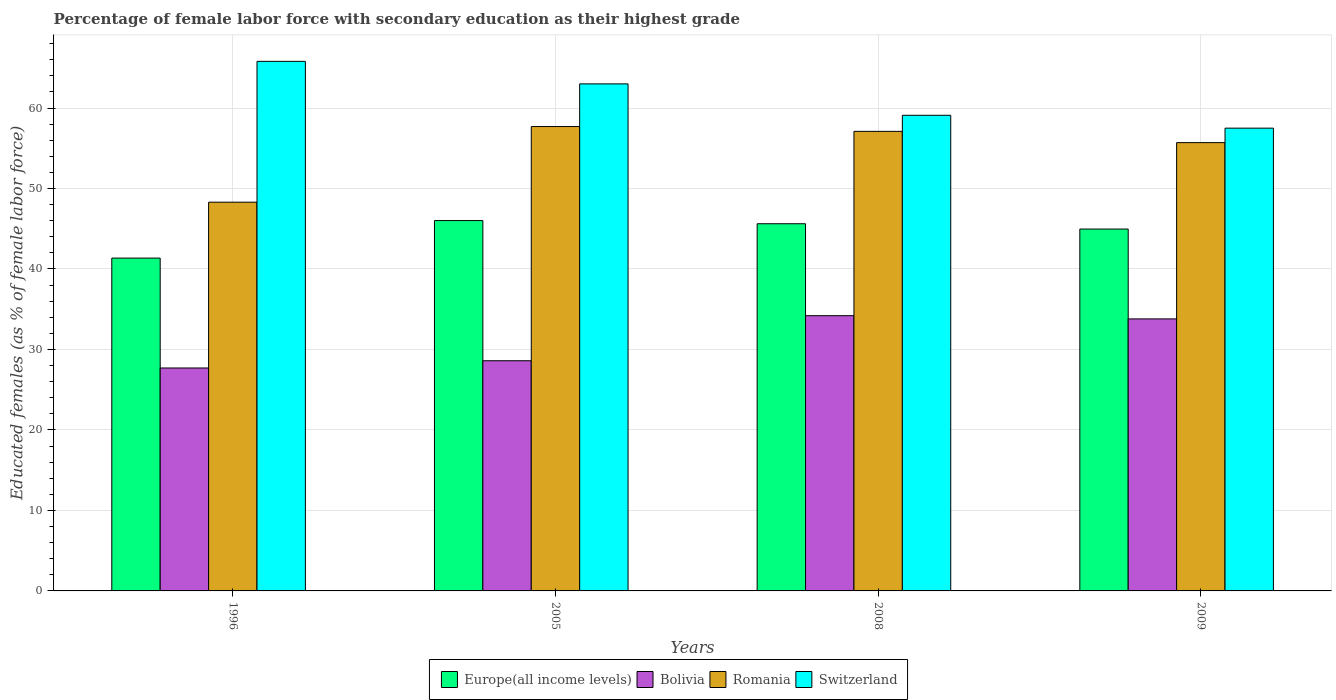Are the number of bars on each tick of the X-axis equal?
Your answer should be compact. Yes. How many bars are there on the 4th tick from the left?
Make the answer very short. 4. How many bars are there on the 4th tick from the right?
Make the answer very short. 4. What is the label of the 2nd group of bars from the left?
Give a very brief answer. 2005. In how many cases, is the number of bars for a given year not equal to the number of legend labels?
Keep it short and to the point. 0. What is the percentage of female labor force with secondary education in Switzerland in 1996?
Make the answer very short. 65.8. Across all years, what is the maximum percentage of female labor force with secondary education in Europe(all income levels)?
Make the answer very short. 46.02. Across all years, what is the minimum percentage of female labor force with secondary education in Romania?
Offer a terse response. 48.3. In which year was the percentage of female labor force with secondary education in Switzerland maximum?
Offer a terse response. 1996. What is the total percentage of female labor force with secondary education in Bolivia in the graph?
Make the answer very short. 124.3. What is the difference between the percentage of female labor force with secondary education in Switzerland in 1996 and that in 2005?
Offer a terse response. 2.8. What is the difference between the percentage of female labor force with secondary education in Switzerland in 2005 and the percentage of female labor force with secondary education in Bolivia in 2009?
Your response must be concise. 29.2. What is the average percentage of female labor force with secondary education in Europe(all income levels) per year?
Provide a succinct answer. 44.49. In the year 2009, what is the difference between the percentage of female labor force with secondary education in Switzerland and percentage of female labor force with secondary education in Romania?
Offer a terse response. 1.8. In how many years, is the percentage of female labor force with secondary education in Switzerland greater than 66 %?
Provide a succinct answer. 0. What is the ratio of the percentage of female labor force with secondary education in Europe(all income levels) in 1996 to that in 2009?
Give a very brief answer. 0.92. What is the difference between the highest and the second highest percentage of female labor force with secondary education in Europe(all income levels)?
Your answer should be compact. 0.39. What is the difference between the highest and the lowest percentage of female labor force with secondary education in Europe(all income levels)?
Keep it short and to the point. 4.66. In how many years, is the percentage of female labor force with secondary education in Switzerland greater than the average percentage of female labor force with secondary education in Switzerland taken over all years?
Provide a succinct answer. 2. Is the sum of the percentage of female labor force with secondary education in Europe(all income levels) in 1996 and 2005 greater than the maximum percentage of female labor force with secondary education in Bolivia across all years?
Offer a very short reply. Yes. What does the 4th bar from the left in 2009 represents?
Keep it short and to the point. Switzerland. What does the 2nd bar from the right in 2009 represents?
Give a very brief answer. Romania. Is it the case that in every year, the sum of the percentage of female labor force with secondary education in Europe(all income levels) and percentage of female labor force with secondary education in Romania is greater than the percentage of female labor force with secondary education in Bolivia?
Your answer should be very brief. Yes. How many years are there in the graph?
Ensure brevity in your answer.  4. Are the values on the major ticks of Y-axis written in scientific E-notation?
Make the answer very short. No. Does the graph contain any zero values?
Your answer should be compact. No. Does the graph contain grids?
Keep it short and to the point. Yes. Where does the legend appear in the graph?
Offer a terse response. Bottom center. How many legend labels are there?
Make the answer very short. 4. How are the legend labels stacked?
Keep it short and to the point. Horizontal. What is the title of the graph?
Offer a very short reply. Percentage of female labor force with secondary education as their highest grade. What is the label or title of the X-axis?
Your answer should be very brief. Years. What is the label or title of the Y-axis?
Ensure brevity in your answer.  Educated females (as % of female labor force). What is the Educated females (as % of female labor force) in Europe(all income levels) in 1996?
Provide a short and direct response. 41.35. What is the Educated females (as % of female labor force) of Bolivia in 1996?
Your answer should be compact. 27.7. What is the Educated females (as % of female labor force) of Romania in 1996?
Provide a succinct answer. 48.3. What is the Educated females (as % of female labor force) of Switzerland in 1996?
Offer a very short reply. 65.8. What is the Educated females (as % of female labor force) in Europe(all income levels) in 2005?
Ensure brevity in your answer.  46.02. What is the Educated females (as % of female labor force) of Bolivia in 2005?
Give a very brief answer. 28.6. What is the Educated females (as % of female labor force) of Romania in 2005?
Provide a succinct answer. 57.7. What is the Educated females (as % of female labor force) of Europe(all income levels) in 2008?
Offer a very short reply. 45.62. What is the Educated females (as % of female labor force) in Bolivia in 2008?
Provide a succinct answer. 34.2. What is the Educated females (as % of female labor force) of Romania in 2008?
Provide a short and direct response. 57.1. What is the Educated females (as % of female labor force) in Switzerland in 2008?
Make the answer very short. 59.1. What is the Educated females (as % of female labor force) in Europe(all income levels) in 2009?
Ensure brevity in your answer.  44.96. What is the Educated females (as % of female labor force) of Bolivia in 2009?
Offer a very short reply. 33.8. What is the Educated females (as % of female labor force) of Romania in 2009?
Provide a short and direct response. 55.7. What is the Educated females (as % of female labor force) in Switzerland in 2009?
Your answer should be compact. 57.5. Across all years, what is the maximum Educated females (as % of female labor force) in Europe(all income levels)?
Offer a terse response. 46.02. Across all years, what is the maximum Educated females (as % of female labor force) of Bolivia?
Make the answer very short. 34.2. Across all years, what is the maximum Educated females (as % of female labor force) in Romania?
Keep it short and to the point. 57.7. Across all years, what is the maximum Educated females (as % of female labor force) in Switzerland?
Your answer should be very brief. 65.8. Across all years, what is the minimum Educated females (as % of female labor force) in Europe(all income levels)?
Keep it short and to the point. 41.35. Across all years, what is the minimum Educated females (as % of female labor force) in Bolivia?
Your response must be concise. 27.7. Across all years, what is the minimum Educated females (as % of female labor force) of Romania?
Provide a short and direct response. 48.3. Across all years, what is the minimum Educated females (as % of female labor force) in Switzerland?
Make the answer very short. 57.5. What is the total Educated females (as % of female labor force) in Europe(all income levels) in the graph?
Offer a very short reply. 177.96. What is the total Educated females (as % of female labor force) in Bolivia in the graph?
Your answer should be compact. 124.3. What is the total Educated females (as % of female labor force) of Romania in the graph?
Your response must be concise. 218.8. What is the total Educated females (as % of female labor force) in Switzerland in the graph?
Your response must be concise. 245.4. What is the difference between the Educated females (as % of female labor force) of Europe(all income levels) in 1996 and that in 2005?
Your answer should be compact. -4.66. What is the difference between the Educated females (as % of female labor force) of Romania in 1996 and that in 2005?
Make the answer very short. -9.4. What is the difference between the Educated females (as % of female labor force) in Europe(all income levels) in 1996 and that in 2008?
Your answer should be compact. -4.27. What is the difference between the Educated females (as % of female labor force) of Bolivia in 1996 and that in 2008?
Provide a short and direct response. -6.5. What is the difference between the Educated females (as % of female labor force) in Romania in 1996 and that in 2008?
Your answer should be very brief. -8.8. What is the difference between the Educated females (as % of female labor force) of Switzerland in 1996 and that in 2008?
Offer a terse response. 6.7. What is the difference between the Educated females (as % of female labor force) of Europe(all income levels) in 1996 and that in 2009?
Make the answer very short. -3.61. What is the difference between the Educated females (as % of female labor force) in Bolivia in 1996 and that in 2009?
Make the answer very short. -6.1. What is the difference between the Educated females (as % of female labor force) in Romania in 1996 and that in 2009?
Your answer should be compact. -7.4. What is the difference between the Educated females (as % of female labor force) in Switzerland in 1996 and that in 2009?
Make the answer very short. 8.3. What is the difference between the Educated females (as % of female labor force) in Europe(all income levels) in 2005 and that in 2008?
Your answer should be compact. 0.39. What is the difference between the Educated females (as % of female labor force) in Bolivia in 2005 and that in 2008?
Make the answer very short. -5.6. What is the difference between the Educated females (as % of female labor force) in Europe(all income levels) in 2005 and that in 2009?
Your answer should be very brief. 1.05. What is the difference between the Educated females (as % of female labor force) in Switzerland in 2005 and that in 2009?
Provide a short and direct response. 5.5. What is the difference between the Educated females (as % of female labor force) in Europe(all income levels) in 2008 and that in 2009?
Provide a short and direct response. 0.66. What is the difference between the Educated females (as % of female labor force) of Romania in 2008 and that in 2009?
Your response must be concise. 1.4. What is the difference between the Educated females (as % of female labor force) in Europe(all income levels) in 1996 and the Educated females (as % of female labor force) in Bolivia in 2005?
Your answer should be very brief. 12.75. What is the difference between the Educated females (as % of female labor force) of Europe(all income levels) in 1996 and the Educated females (as % of female labor force) of Romania in 2005?
Provide a short and direct response. -16.35. What is the difference between the Educated females (as % of female labor force) in Europe(all income levels) in 1996 and the Educated females (as % of female labor force) in Switzerland in 2005?
Offer a terse response. -21.65. What is the difference between the Educated females (as % of female labor force) of Bolivia in 1996 and the Educated females (as % of female labor force) of Romania in 2005?
Your answer should be very brief. -30. What is the difference between the Educated females (as % of female labor force) in Bolivia in 1996 and the Educated females (as % of female labor force) in Switzerland in 2005?
Your answer should be very brief. -35.3. What is the difference between the Educated females (as % of female labor force) of Romania in 1996 and the Educated females (as % of female labor force) of Switzerland in 2005?
Give a very brief answer. -14.7. What is the difference between the Educated females (as % of female labor force) in Europe(all income levels) in 1996 and the Educated females (as % of female labor force) in Bolivia in 2008?
Keep it short and to the point. 7.15. What is the difference between the Educated females (as % of female labor force) in Europe(all income levels) in 1996 and the Educated females (as % of female labor force) in Romania in 2008?
Your answer should be compact. -15.75. What is the difference between the Educated females (as % of female labor force) in Europe(all income levels) in 1996 and the Educated females (as % of female labor force) in Switzerland in 2008?
Keep it short and to the point. -17.75. What is the difference between the Educated females (as % of female labor force) in Bolivia in 1996 and the Educated females (as % of female labor force) in Romania in 2008?
Your answer should be compact. -29.4. What is the difference between the Educated females (as % of female labor force) in Bolivia in 1996 and the Educated females (as % of female labor force) in Switzerland in 2008?
Keep it short and to the point. -31.4. What is the difference between the Educated females (as % of female labor force) in Europe(all income levels) in 1996 and the Educated females (as % of female labor force) in Bolivia in 2009?
Give a very brief answer. 7.55. What is the difference between the Educated females (as % of female labor force) of Europe(all income levels) in 1996 and the Educated females (as % of female labor force) of Romania in 2009?
Offer a terse response. -14.35. What is the difference between the Educated females (as % of female labor force) in Europe(all income levels) in 1996 and the Educated females (as % of female labor force) in Switzerland in 2009?
Ensure brevity in your answer.  -16.15. What is the difference between the Educated females (as % of female labor force) of Bolivia in 1996 and the Educated females (as % of female labor force) of Switzerland in 2009?
Your answer should be compact. -29.8. What is the difference between the Educated females (as % of female labor force) of Europe(all income levels) in 2005 and the Educated females (as % of female labor force) of Bolivia in 2008?
Provide a succinct answer. 11.82. What is the difference between the Educated females (as % of female labor force) of Europe(all income levels) in 2005 and the Educated females (as % of female labor force) of Romania in 2008?
Give a very brief answer. -11.08. What is the difference between the Educated females (as % of female labor force) of Europe(all income levels) in 2005 and the Educated females (as % of female labor force) of Switzerland in 2008?
Keep it short and to the point. -13.08. What is the difference between the Educated females (as % of female labor force) of Bolivia in 2005 and the Educated females (as % of female labor force) of Romania in 2008?
Offer a very short reply. -28.5. What is the difference between the Educated females (as % of female labor force) of Bolivia in 2005 and the Educated females (as % of female labor force) of Switzerland in 2008?
Offer a very short reply. -30.5. What is the difference between the Educated females (as % of female labor force) in Romania in 2005 and the Educated females (as % of female labor force) in Switzerland in 2008?
Your response must be concise. -1.4. What is the difference between the Educated females (as % of female labor force) of Europe(all income levels) in 2005 and the Educated females (as % of female labor force) of Bolivia in 2009?
Your answer should be very brief. 12.22. What is the difference between the Educated females (as % of female labor force) in Europe(all income levels) in 2005 and the Educated females (as % of female labor force) in Romania in 2009?
Your answer should be very brief. -9.68. What is the difference between the Educated females (as % of female labor force) of Europe(all income levels) in 2005 and the Educated females (as % of female labor force) of Switzerland in 2009?
Provide a short and direct response. -11.48. What is the difference between the Educated females (as % of female labor force) of Bolivia in 2005 and the Educated females (as % of female labor force) of Romania in 2009?
Your response must be concise. -27.1. What is the difference between the Educated females (as % of female labor force) of Bolivia in 2005 and the Educated females (as % of female labor force) of Switzerland in 2009?
Offer a terse response. -28.9. What is the difference between the Educated females (as % of female labor force) of Romania in 2005 and the Educated females (as % of female labor force) of Switzerland in 2009?
Offer a terse response. 0.2. What is the difference between the Educated females (as % of female labor force) in Europe(all income levels) in 2008 and the Educated females (as % of female labor force) in Bolivia in 2009?
Provide a short and direct response. 11.82. What is the difference between the Educated females (as % of female labor force) of Europe(all income levels) in 2008 and the Educated females (as % of female labor force) of Romania in 2009?
Offer a very short reply. -10.08. What is the difference between the Educated females (as % of female labor force) of Europe(all income levels) in 2008 and the Educated females (as % of female labor force) of Switzerland in 2009?
Ensure brevity in your answer.  -11.88. What is the difference between the Educated females (as % of female labor force) in Bolivia in 2008 and the Educated females (as % of female labor force) in Romania in 2009?
Make the answer very short. -21.5. What is the difference between the Educated females (as % of female labor force) of Bolivia in 2008 and the Educated females (as % of female labor force) of Switzerland in 2009?
Provide a short and direct response. -23.3. What is the difference between the Educated females (as % of female labor force) in Romania in 2008 and the Educated females (as % of female labor force) in Switzerland in 2009?
Offer a terse response. -0.4. What is the average Educated females (as % of female labor force) of Europe(all income levels) per year?
Provide a succinct answer. 44.49. What is the average Educated females (as % of female labor force) in Bolivia per year?
Give a very brief answer. 31.07. What is the average Educated females (as % of female labor force) of Romania per year?
Your answer should be very brief. 54.7. What is the average Educated females (as % of female labor force) of Switzerland per year?
Provide a short and direct response. 61.35. In the year 1996, what is the difference between the Educated females (as % of female labor force) in Europe(all income levels) and Educated females (as % of female labor force) in Bolivia?
Provide a short and direct response. 13.65. In the year 1996, what is the difference between the Educated females (as % of female labor force) in Europe(all income levels) and Educated females (as % of female labor force) in Romania?
Offer a terse response. -6.95. In the year 1996, what is the difference between the Educated females (as % of female labor force) in Europe(all income levels) and Educated females (as % of female labor force) in Switzerland?
Provide a short and direct response. -24.45. In the year 1996, what is the difference between the Educated females (as % of female labor force) of Bolivia and Educated females (as % of female labor force) of Romania?
Make the answer very short. -20.6. In the year 1996, what is the difference between the Educated females (as % of female labor force) in Bolivia and Educated females (as % of female labor force) in Switzerland?
Your response must be concise. -38.1. In the year 1996, what is the difference between the Educated females (as % of female labor force) of Romania and Educated females (as % of female labor force) of Switzerland?
Provide a succinct answer. -17.5. In the year 2005, what is the difference between the Educated females (as % of female labor force) in Europe(all income levels) and Educated females (as % of female labor force) in Bolivia?
Make the answer very short. 17.42. In the year 2005, what is the difference between the Educated females (as % of female labor force) in Europe(all income levels) and Educated females (as % of female labor force) in Romania?
Your answer should be compact. -11.68. In the year 2005, what is the difference between the Educated females (as % of female labor force) of Europe(all income levels) and Educated females (as % of female labor force) of Switzerland?
Your answer should be compact. -16.98. In the year 2005, what is the difference between the Educated females (as % of female labor force) in Bolivia and Educated females (as % of female labor force) in Romania?
Your response must be concise. -29.1. In the year 2005, what is the difference between the Educated females (as % of female labor force) in Bolivia and Educated females (as % of female labor force) in Switzerland?
Make the answer very short. -34.4. In the year 2008, what is the difference between the Educated females (as % of female labor force) of Europe(all income levels) and Educated females (as % of female labor force) of Bolivia?
Make the answer very short. 11.42. In the year 2008, what is the difference between the Educated females (as % of female labor force) of Europe(all income levels) and Educated females (as % of female labor force) of Romania?
Your response must be concise. -11.48. In the year 2008, what is the difference between the Educated females (as % of female labor force) of Europe(all income levels) and Educated females (as % of female labor force) of Switzerland?
Make the answer very short. -13.48. In the year 2008, what is the difference between the Educated females (as % of female labor force) in Bolivia and Educated females (as % of female labor force) in Romania?
Provide a short and direct response. -22.9. In the year 2008, what is the difference between the Educated females (as % of female labor force) in Bolivia and Educated females (as % of female labor force) in Switzerland?
Offer a terse response. -24.9. In the year 2009, what is the difference between the Educated females (as % of female labor force) in Europe(all income levels) and Educated females (as % of female labor force) in Bolivia?
Provide a succinct answer. 11.16. In the year 2009, what is the difference between the Educated females (as % of female labor force) of Europe(all income levels) and Educated females (as % of female labor force) of Romania?
Provide a succinct answer. -10.74. In the year 2009, what is the difference between the Educated females (as % of female labor force) in Europe(all income levels) and Educated females (as % of female labor force) in Switzerland?
Offer a very short reply. -12.54. In the year 2009, what is the difference between the Educated females (as % of female labor force) in Bolivia and Educated females (as % of female labor force) in Romania?
Offer a terse response. -21.9. In the year 2009, what is the difference between the Educated females (as % of female labor force) of Bolivia and Educated females (as % of female labor force) of Switzerland?
Your answer should be compact. -23.7. What is the ratio of the Educated females (as % of female labor force) of Europe(all income levels) in 1996 to that in 2005?
Offer a terse response. 0.9. What is the ratio of the Educated females (as % of female labor force) in Bolivia in 1996 to that in 2005?
Offer a very short reply. 0.97. What is the ratio of the Educated females (as % of female labor force) of Romania in 1996 to that in 2005?
Make the answer very short. 0.84. What is the ratio of the Educated females (as % of female labor force) of Switzerland in 1996 to that in 2005?
Give a very brief answer. 1.04. What is the ratio of the Educated females (as % of female labor force) in Europe(all income levels) in 1996 to that in 2008?
Keep it short and to the point. 0.91. What is the ratio of the Educated females (as % of female labor force) in Bolivia in 1996 to that in 2008?
Offer a very short reply. 0.81. What is the ratio of the Educated females (as % of female labor force) of Romania in 1996 to that in 2008?
Make the answer very short. 0.85. What is the ratio of the Educated females (as % of female labor force) in Switzerland in 1996 to that in 2008?
Offer a terse response. 1.11. What is the ratio of the Educated females (as % of female labor force) of Europe(all income levels) in 1996 to that in 2009?
Provide a succinct answer. 0.92. What is the ratio of the Educated females (as % of female labor force) in Bolivia in 1996 to that in 2009?
Give a very brief answer. 0.82. What is the ratio of the Educated females (as % of female labor force) of Romania in 1996 to that in 2009?
Your response must be concise. 0.87. What is the ratio of the Educated females (as % of female labor force) in Switzerland in 1996 to that in 2009?
Provide a succinct answer. 1.14. What is the ratio of the Educated females (as % of female labor force) in Europe(all income levels) in 2005 to that in 2008?
Ensure brevity in your answer.  1.01. What is the ratio of the Educated females (as % of female labor force) of Bolivia in 2005 to that in 2008?
Ensure brevity in your answer.  0.84. What is the ratio of the Educated females (as % of female labor force) in Romania in 2005 to that in 2008?
Provide a succinct answer. 1.01. What is the ratio of the Educated females (as % of female labor force) of Switzerland in 2005 to that in 2008?
Your response must be concise. 1.07. What is the ratio of the Educated females (as % of female labor force) of Europe(all income levels) in 2005 to that in 2009?
Offer a very short reply. 1.02. What is the ratio of the Educated females (as % of female labor force) in Bolivia in 2005 to that in 2009?
Your answer should be very brief. 0.85. What is the ratio of the Educated females (as % of female labor force) of Romania in 2005 to that in 2009?
Give a very brief answer. 1.04. What is the ratio of the Educated females (as % of female labor force) in Switzerland in 2005 to that in 2009?
Keep it short and to the point. 1.1. What is the ratio of the Educated females (as % of female labor force) of Europe(all income levels) in 2008 to that in 2009?
Make the answer very short. 1.01. What is the ratio of the Educated females (as % of female labor force) in Bolivia in 2008 to that in 2009?
Ensure brevity in your answer.  1.01. What is the ratio of the Educated females (as % of female labor force) in Romania in 2008 to that in 2009?
Your response must be concise. 1.03. What is the ratio of the Educated females (as % of female labor force) in Switzerland in 2008 to that in 2009?
Provide a succinct answer. 1.03. What is the difference between the highest and the second highest Educated females (as % of female labor force) in Europe(all income levels)?
Ensure brevity in your answer.  0.39. What is the difference between the highest and the second highest Educated females (as % of female labor force) in Switzerland?
Provide a short and direct response. 2.8. What is the difference between the highest and the lowest Educated females (as % of female labor force) in Europe(all income levels)?
Your answer should be compact. 4.66. What is the difference between the highest and the lowest Educated females (as % of female labor force) of Romania?
Your answer should be very brief. 9.4. 